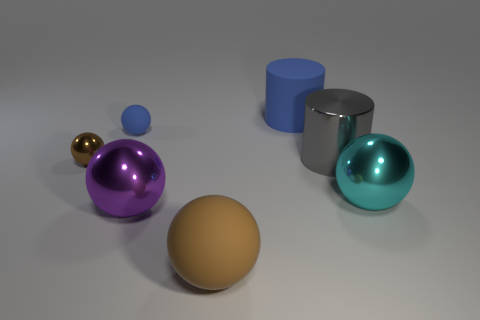Are there an equal number of tiny rubber objects in front of the cyan object and big rubber cylinders?
Ensure brevity in your answer.  No. What number of other objects are there of the same size as the metallic cylinder?
Give a very brief answer. 4. Do the blue thing that is on the right side of the tiny blue matte thing and the blue thing that is left of the large brown rubber object have the same material?
Ensure brevity in your answer.  Yes. There is a blue matte object that is in front of the large matte thing behind the small blue thing; what size is it?
Make the answer very short. Small. Are there any tiny spheres of the same color as the large rubber cylinder?
Provide a succinct answer. Yes. There is a rubber thing that is in front of the big gray object; is its color the same as the tiny shiny sphere in front of the blue cylinder?
Ensure brevity in your answer.  Yes. The brown metal object is what shape?
Keep it short and to the point. Sphere. There is a brown rubber sphere; how many tiny blue things are to the right of it?
Provide a succinct answer. 0. How many blue spheres have the same material as the gray cylinder?
Your answer should be compact. 0. Are the large cylinder that is behind the small rubber sphere and the cyan object made of the same material?
Provide a short and direct response. No. 